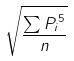Convert formula to latex. <formula><loc_0><loc_0><loc_500><loc_500>\sqrt { \frac { \sum { P _ { i } } ^ { 5 } } { n } }</formula> 